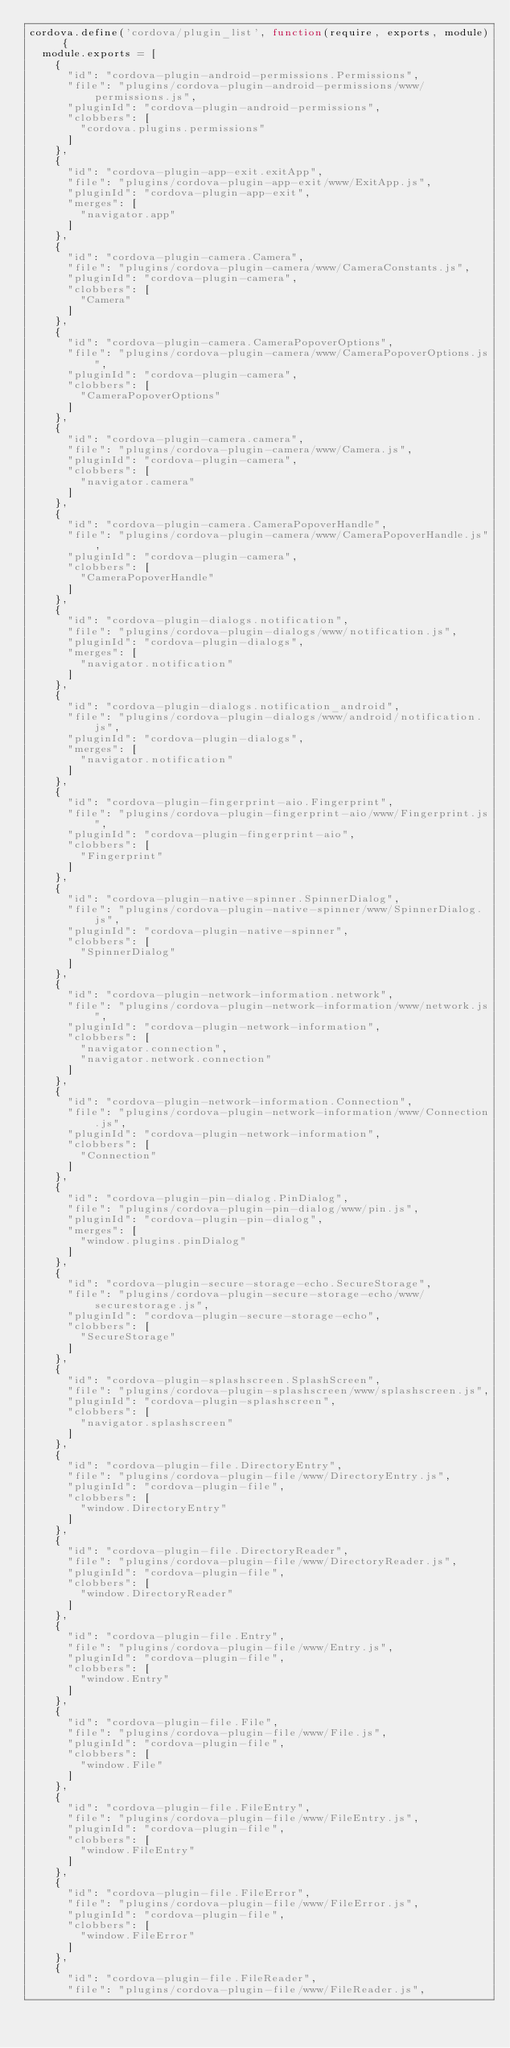<code> <loc_0><loc_0><loc_500><loc_500><_JavaScript_>cordova.define('cordova/plugin_list', function(require, exports, module) {
  module.exports = [
    {
      "id": "cordova-plugin-android-permissions.Permissions",
      "file": "plugins/cordova-plugin-android-permissions/www/permissions.js",
      "pluginId": "cordova-plugin-android-permissions",
      "clobbers": [
        "cordova.plugins.permissions"
      ]
    },
    {
      "id": "cordova-plugin-app-exit.exitApp",
      "file": "plugins/cordova-plugin-app-exit/www/ExitApp.js",
      "pluginId": "cordova-plugin-app-exit",
      "merges": [
        "navigator.app"
      ]
    },
    {
      "id": "cordova-plugin-camera.Camera",
      "file": "plugins/cordova-plugin-camera/www/CameraConstants.js",
      "pluginId": "cordova-plugin-camera",
      "clobbers": [
        "Camera"
      ]
    },
    {
      "id": "cordova-plugin-camera.CameraPopoverOptions",
      "file": "plugins/cordova-plugin-camera/www/CameraPopoverOptions.js",
      "pluginId": "cordova-plugin-camera",
      "clobbers": [
        "CameraPopoverOptions"
      ]
    },
    {
      "id": "cordova-plugin-camera.camera",
      "file": "plugins/cordova-plugin-camera/www/Camera.js",
      "pluginId": "cordova-plugin-camera",
      "clobbers": [
        "navigator.camera"
      ]
    },
    {
      "id": "cordova-plugin-camera.CameraPopoverHandle",
      "file": "plugins/cordova-plugin-camera/www/CameraPopoverHandle.js",
      "pluginId": "cordova-plugin-camera",
      "clobbers": [
        "CameraPopoverHandle"
      ]
    },
    {
      "id": "cordova-plugin-dialogs.notification",
      "file": "plugins/cordova-plugin-dialogs/www/notification.js",
      "pluginId": "cordova-plugin-dialogs",
      "merges": [
        "navigator.notification"
      ]
    },
    {
      "id": "cordova-plugin-dialogs.notification_android",
      "file": "plugins/cordova-plugin-dialogs/www/android/notification.js",
      "pluginId": "cordova-plugin-dialogs",
      "merges": [
        "navigator.notification"
      ]
    },
    {
      "id": "cordova-plugin-fingerprint-aio.Fingerprint",
      "file": "plugins/cordova-plugin-fingerprint-aio/www/Fingerprint.js",
      "pluginId": "cordova-plugin-fingerprint-aio",
      "clobbers": [
        "Fingerprint"
      ]
    },
    {
      "id": "cordova-plugin-native-spinner.SpinnerDialog",
      "file": "plugins/cordova-plugin-native-spinner/www/SpinnerDialog.js",
      "pluginId": "cordova-plugin-native-spinner",
      "clobbers": [
        "SpinnerDialog"
      ]
    },
    {
      "id": "cordova-plugin-network-information.network",
      "file": "plugins/cordova-plugin-network-information/www/network.js",
      "pluginId": "cordova-plugin-network-information",
      "clobbers": [
        "navigator.connection",
        "navigator.network.connection"
      ]
    },
    {
      "id": "cordova-plugin-network-information.Connection",
      "file": "plugins/cordova-plugin-network-information/www/Connection.js",
      "pluginId": "cordova-plugin-network-information",
      "clobbers": [
        "Connection"
      ]
    },
    {
      "id": "cordova-plugin-pin-dialog.PinDialog",
      "file": "plugins/cordova-plugin-pin-dialog/www/pin.js",
      "pluginId": "cordova-plugin-pin-dialog",
      "merges": [
        "window.plugins.pinDialog"
      ]
    },
    {
      "id": "cordova-plugin-secure-storage-echo.SecureStorage",
      "file": "plugins/cordova-plugin-secure-storage-echo/www/securestorage.js",
      "pluginId": "cordova-plugin-secure-storage-echo",
      "clobbers": [
        "SecureStorage"
      ]
    },
    {
      "id": "cordova-plugin-splashscreen.SplashScreen",
      "file": "plugins/cordova-plugin-splashscreen/www/splashscreen.js",
      "pluginId": "cordova-plugin-splashscreen",
      "clobbers": [
        "navigator.splashscreen"
      ]
    },
    {
      "id": "cordova-plugin-file.DirectoryEntry",
      "file": "plugins/cordova-plugin-file/www/DirectoryEntry.js",
      "pluginId": "cordova-plugin-file",
      "clobbers": [
        "window.DirectoryEntry"
      ]
    },
    {
      "id": "cordova-plugin-file.DirectoryReader",
      "file": "plugins/cordova-plugin-file/www/DirectoryReader.js",
      "pluginId": "cordova-plugin-file",
      "clobbers": [
        "window.DirectoryReader"
      ]
    },
    {
      "id": "cordova-plugin-file.Entry",
      "file": "plugins/cordova-plugin-file/www/Entry.js",
      "pluginId": "cordova-plugin-file",
      "clobbers": [
        "window.Entry"
      ]
    },
    {
      "id": "cordova-plugin-file.File",
      "file": "plugins/cordova-plugin-file/www/File.js",
      "pluginId": "cordova-plugin-file",
      "clobbers": [
        "window.File"
      ]
    },
    {
      "id": "cordova-plugin-file.FileEntry",
      "file": "plugins/cordova-plugin-file/www/FileEntry.js",
      "pluginId": "cordova-plugin-file",
      "clobbers": [
        "window.FileEntry"
      ]
    },
    {
      "id": "cordova-plugin-file.FileError",
      "file": "plugins/cordova-plugin-file/www/FileError.js",
      "pluginId": "cordova-plugin-file",
      "clobbers": [
        "window.FileError"
      ]
    },
    {
      "id": "cordova-plugin-file.FileReader",
      "file": "plugins/cordova-plugin-file/www/FileReader.js",</code> 